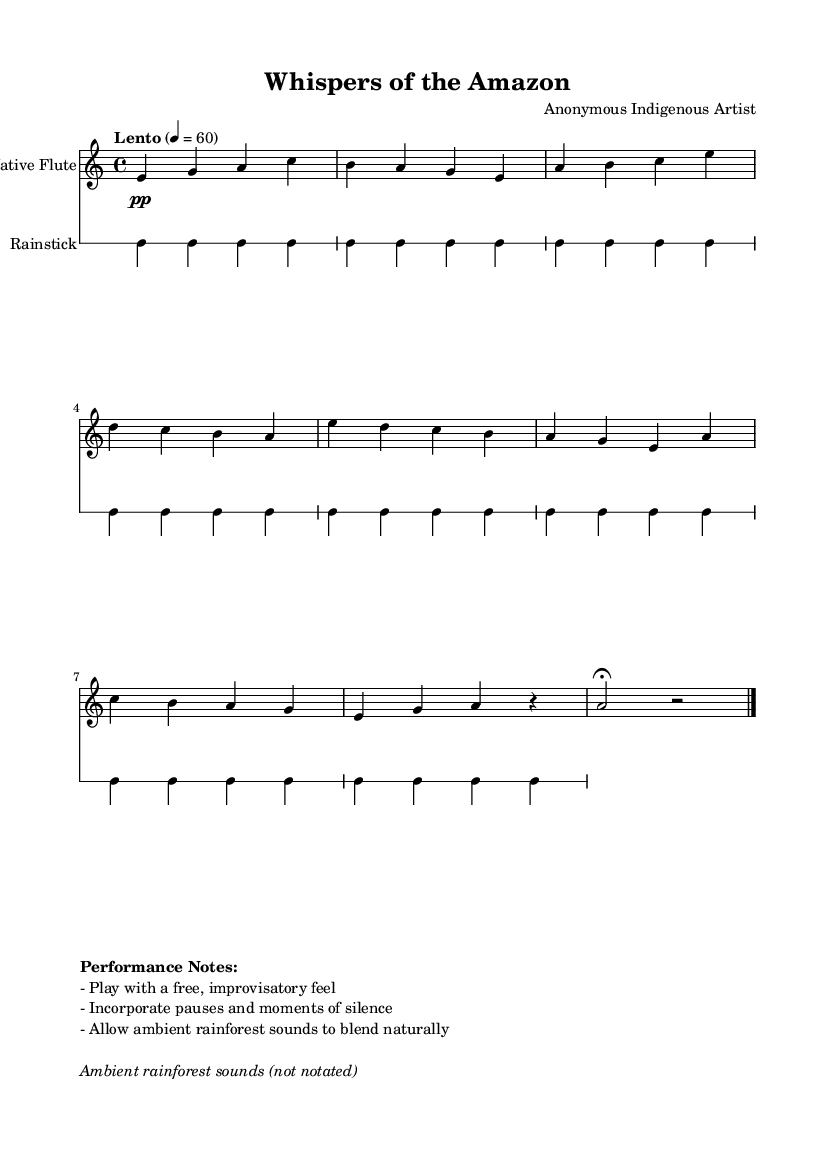What is the key signature of this music? The key signature is A minor, which has no sharps or flats, as indicated in the global section of the code.
Answer: A minor What is the time signature of the piece? The time signature is 4/4, found in the global section of the code that sets the musical parameters.
Answer: 4/4 What is the tempo marking in the score? The score specifies a tempo marking of "Lento," which indicates the speed of the piece. The numerical indication is 4 equals 60 beats per minute.
Answer: Lento How many measures are there in Theme A? Theme A consists of two measures, as indicated by the grouping of notes in the flute part.
Answer: 2 measures What instrument is featured in the score alongside the flute? The score includes a rainstick, which is notated in a separate drum staff alongside the flute.
Answer: Rainstick How many times is the rainstick played in the score? The rainstick is played in a repeated pattern for a total of eight counts (notated as "repeat unfold 8") in the drum staff, which means one full cycle is played eight times.
Answer: 8 What performance notes are provided for this piece? The performance notes suggest playing with a free, improvisatory feel, incorporating pauses, and allowing ambient rainforest sounds to blend which emphasizes the piece's ambient quality.
Answer: Performance notes: free, improvisatory feel 